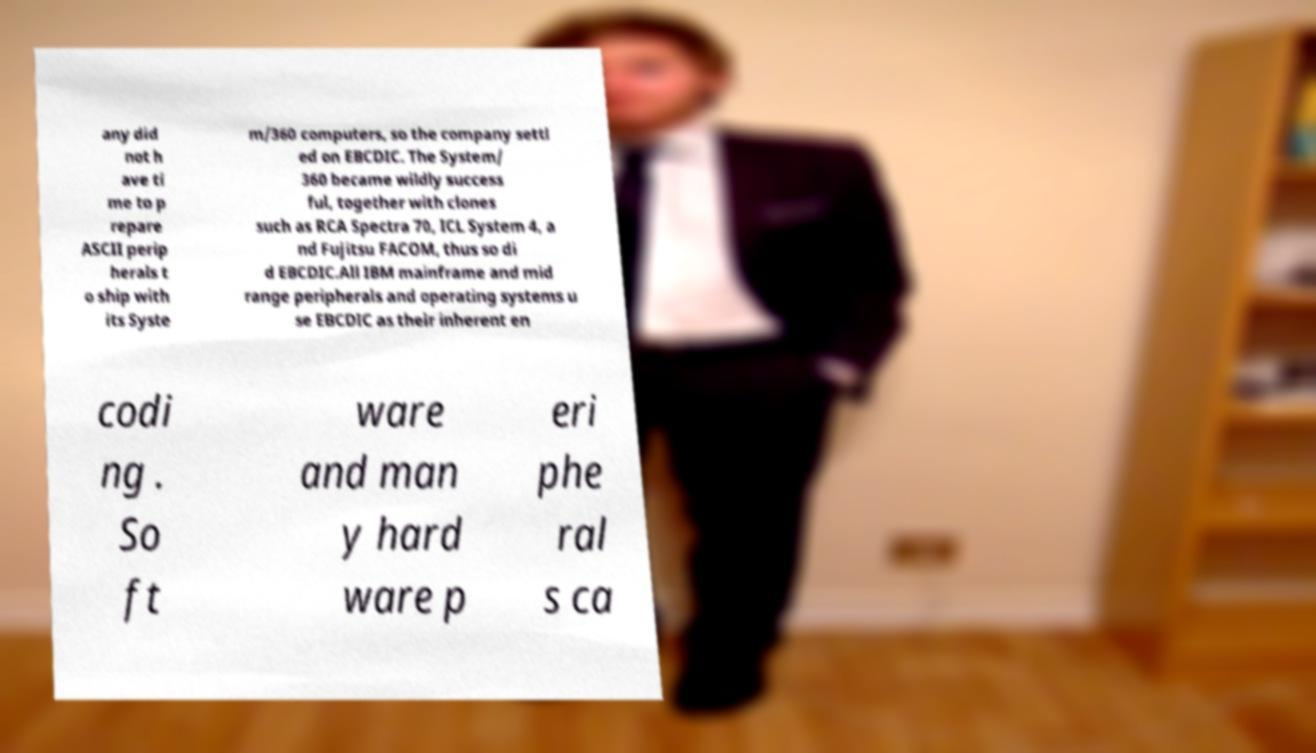Can you accurately transcribe the text from the provided image for me? any did not h ave ti me to p repare ASCII perip herals t o ship with its Syste m/360 computers, so the company settl ed on EBCDIC. The System/ 360 became wildly success ful, together with clones such as RCA Spectra 70, ICL System 4, a nd Fujitsu FACOM, thus so di d EBCDIC.All IBM mainframe and mid range peripherals and operating systems u se EBCDIC as their inherent en codi ng . So ft ware and man y hard ware p eri phe ral s ca 